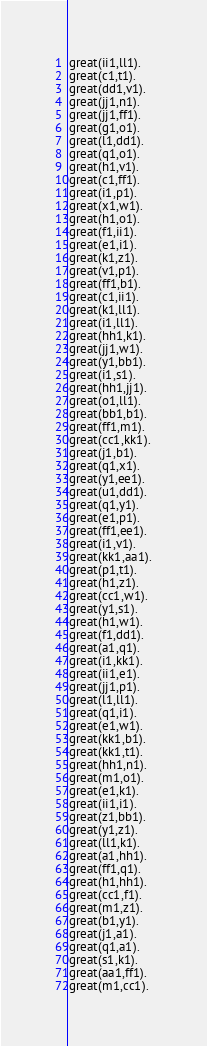<code> <loc_0><loc_0><loc_500><loc_500><_FORTRAN_>great(ii1,ll1).
great(c1,t1).
great(dd1,v1).
great(jj1,n1).
great(jj1,ff1).
great(g1,o1).
great(l1,dd1).
great(q1,o1).
great(h1,v1).
great(c1,ff1).
great(i1,p1).
great(x1,w1).
great(h1,o1).
great(f1,ii1).
great(e1,i1).
great(k1,z1).
great(v1,p1).
great(ff1,b1).
great(c1,ii1).
great(k1,ll1).
great(i1,ll1).
great(hh1,k1).
great(jj1,w1).
great(y1,bb1).
great(i1,s1).
great(hh1,jj1).
great(o1,ll1).
great(bb1,b1).
great(ff1,m1).
great(cc1,kk1).
great(j1,b1).
great(q1,x1).
great(y1,ee1).
great(u1,dd1).
great(q1,y1).
great(e1,p1).
great(ff1,ee1).
great(i1,v1).
great(kk1,aa1).
great(p1,t1).
great(h1,z1).
great(cc1,w1).
great(y1,s1).
great(h1,w1).
great(f1,dd1).
great(a1,q1).
great(i1,kk1).
great(ii1,e1).
great(jj1,p1).
great(l1,ll1).
great(q1,i1).
great(e1,w1).
great(kk1,b1).
great(kk1,t1).
great(hh1,n1).
great(m1,o1).
great(e1,k1).
great(ii1,i1).
great(z1,bb1).
great(y1,z1).
great(ll1,k1).
great(a1,hh1).
great(ff1,q1).
great(h1,hh1).
great(cc1,f1).
great(m1,z1).
great(b1,y1).
great(j1,a1).
great(q1,a1).
great(s1,k1).
great(aa1,ff1).
great(m1,cc1).
</code> 